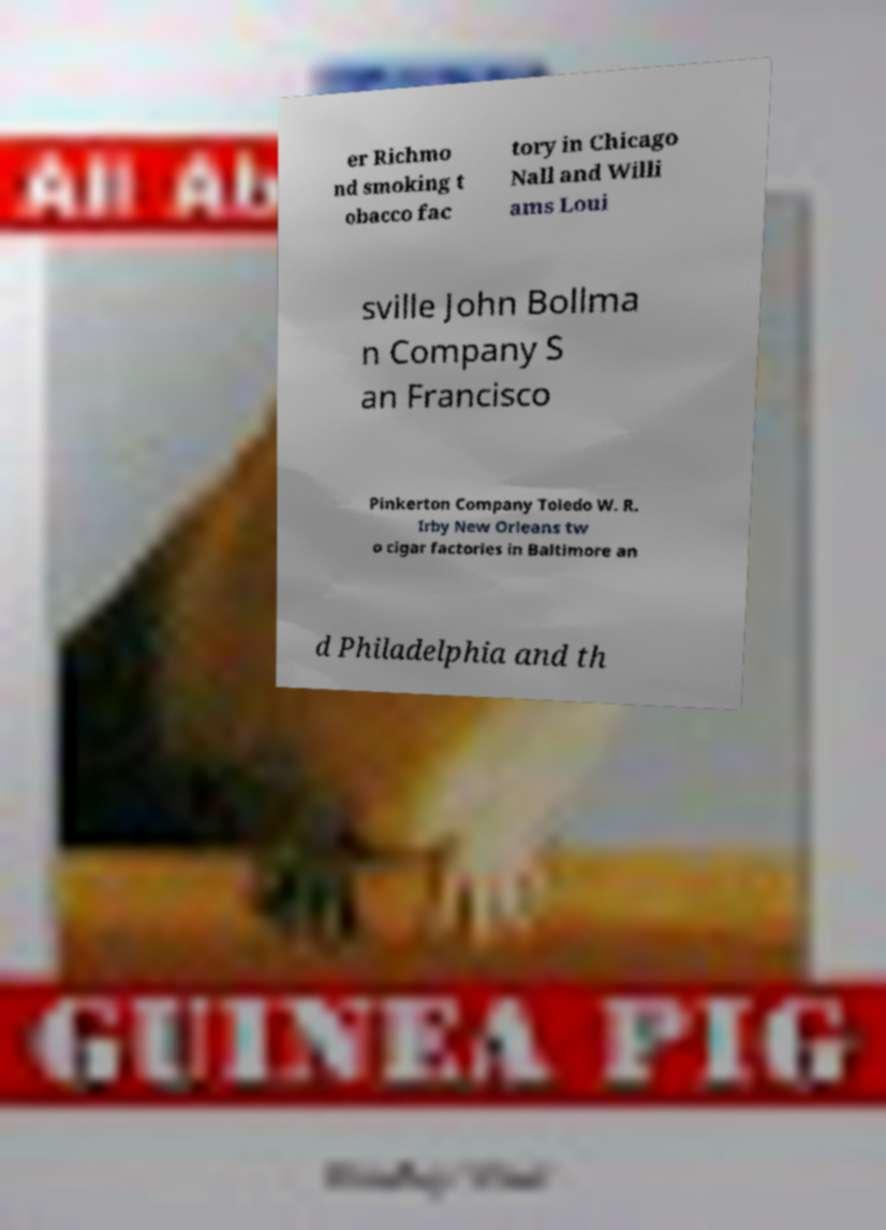Please identify and transcribe the text found in this image. er Richmo nd smoking t obacco fac tory in Chicago Nall and Willi ams Loui sville John Bollma n Company S an Francisco Pinkerton Company Toledo W. R. Irby New Orleans tw o cigar factories in Baltimore an d Philadelphia and th 